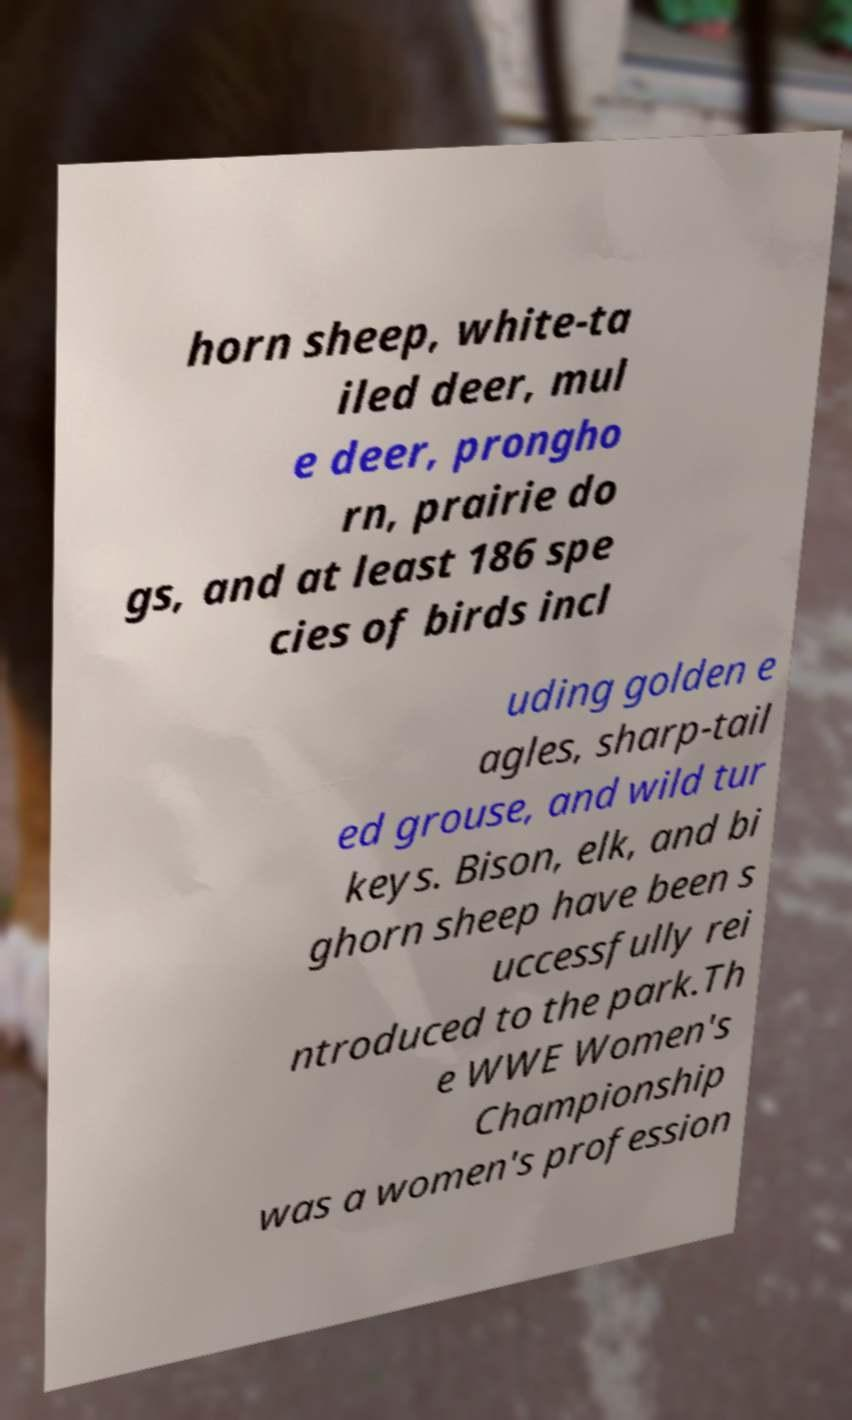Please read and relay the text visible in this image. What does it say? horn sheep, white-ta iled deer, mul e deer, prongho rn, prairie do gs, and at least 186 spe cies of birds incl uding golden e agles, sharp-tail ed grouse, and wild tur keys. Bison, elk, and bi ghorn sheep have been s uccessfully rei ntroduced to the park.Th e WWE Women's Championship was a women's profession 